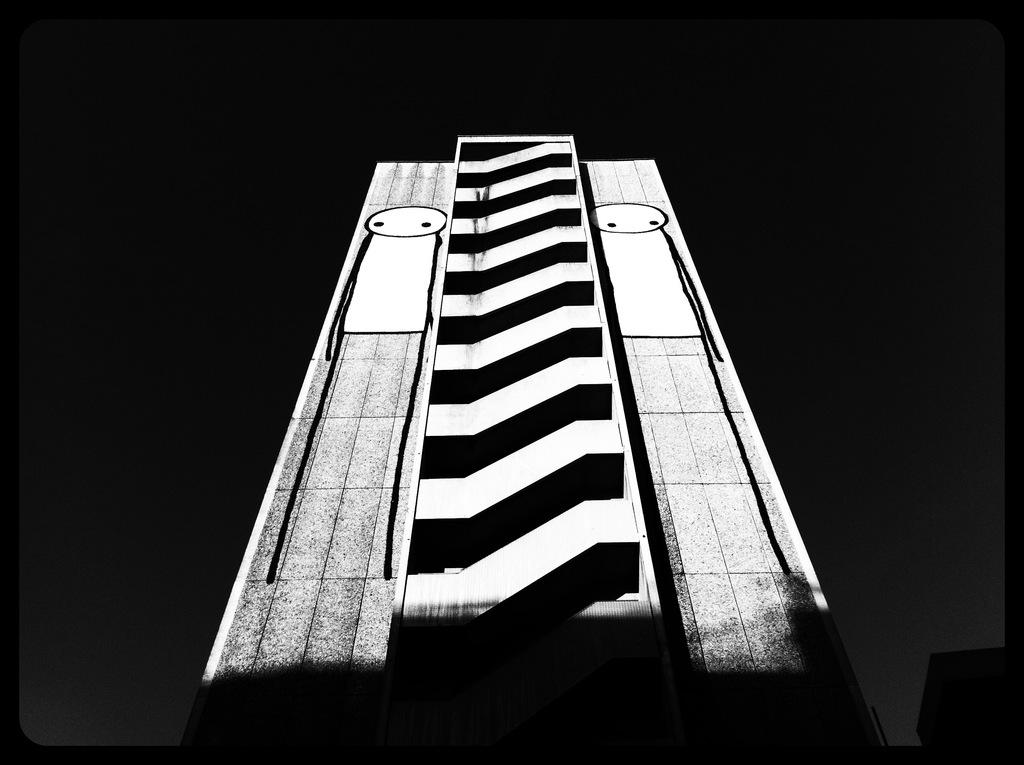What is the main subject of the image? There is a painting in the image. What colors are used in the painting? The painting has white and black colors. What is the color of the surface the painting is on? The painting is on a black color surface. What type of stem can be seen growing from the painting in the image? There is no stem present in the image; it is a painting with white and black colors on a black surface. 